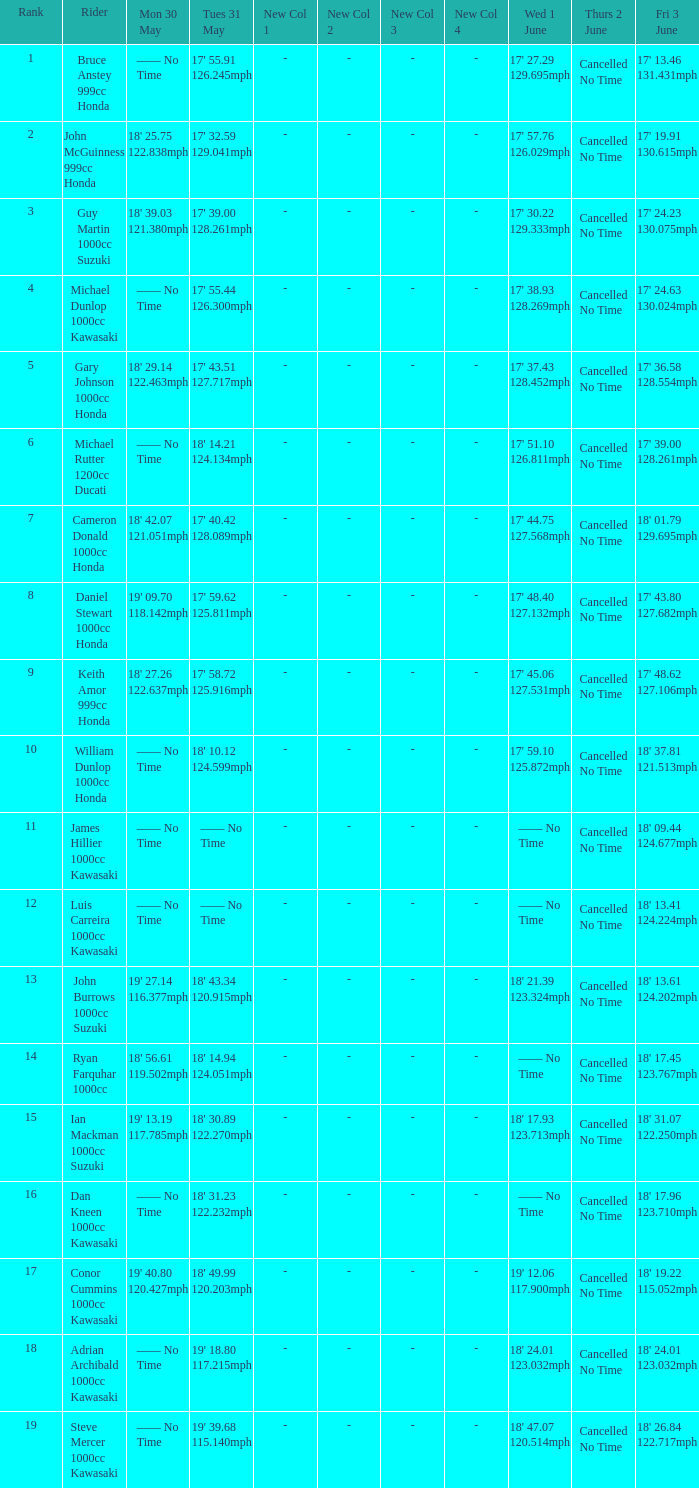What is the Mon 30 May time for the rider whose Fri 3 June time was 17' 13.46 131.431mph? —— No Time. 